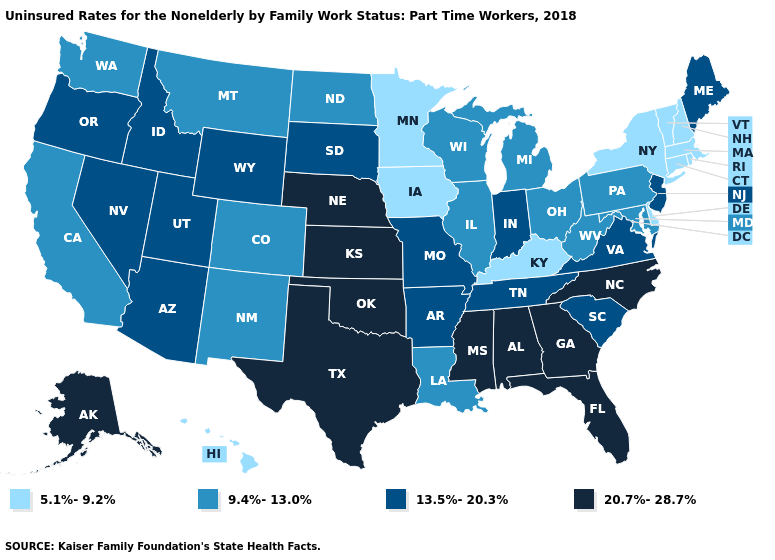Does Mississippi have a higher value than Alaska?
Concise answer only. No. Which states hav the highest value in the West?
Short answer required. Alaska. What is the value of Mississippi?
Be succinct. 20.7%-28.7%. Name the states that have a value in the range 9.4%-13.0%?
Short answer required. California, Colorado, Illinois, Louisiana, Maryland, Michigan, Montana, New Mexico, North Dakota, Ohio, Pennsylvania, Washington, West Virginia, Wisconsin. What is the highest value in states that border Virginia?
Quick response, please. 20.7%-28.7%. Which states have the lowest value in the USA?
Short answer required. Connecticut, Delaware, Hawaii, Iowa, Kentucky, Massachusetts, Minnesota, New Hampshire, New York, Rhode Island, Vermont. What is the value of Massachusetts?
Keep it brief. 5.1%-9.2%. Does the first symbol in the legend represent the smallest category?
Keep it brief. Yes. Does Hawaii have the lowest value in the West?
Short answer required. Yes. What is the value of Iowa?
Answer briefly. 5.1%-9.2%. Among the states that border Washington , which have the lowest value?
Write a very short answer. Idaho, Oregon. What is the value of Virginia?
Short answer required. 13.5%-20.3%. What is the lowest value in states that border Illinois?
Quick response, please. 5.1%-9.2%. Name the states that have a value in the range 9.4%-13.0%?
Keep it brief. California, Colorado, Illinois, Louisiana, Maryland, Michigan, Montana, New Mexico, North Dakota, Ohio, Pennsylvania, Washington, West Virginia, Wisconsin. 